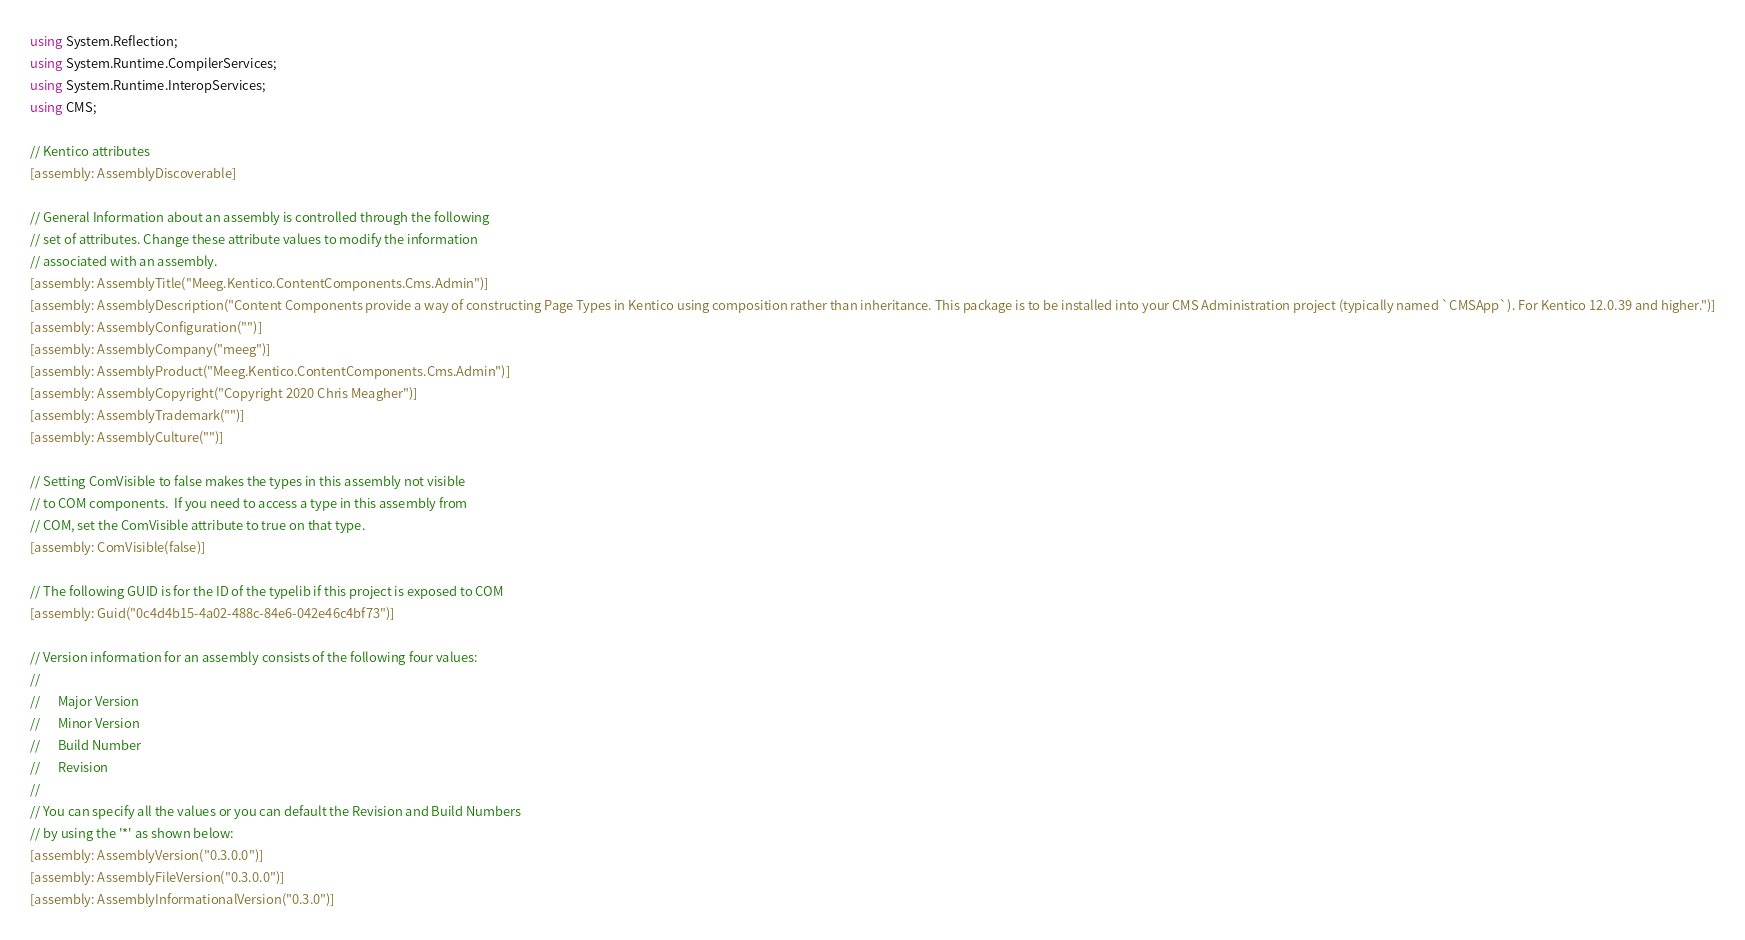<code> <loc_0><loc_0><loc_500><loc_500><_C#_>using System.Reflection;
using System.Runtime.CompilerServices;
using System.Runtime.InteropServices;
using CMS;

// Kentico attributes
[assembly: AssemblyDiscoverable]

// General Information about an assembly is controlled through the following 
// set of attributes. Change these attribute values to modify the information
// associated with an assembly.
[assembly: AssemblyTitle("Meeg.Kentico.ContentComponents.Cms.Admin")]
[assembly: AssemblyDescription("Content Components provide a way of constructing Page Types in Kentico using composition rather than inheritance. This package is to be installed into your CMS Administration project (typically named `CMSApp`). For Kentico 12.0.39 and higher.")]
[assembly: AssemblyConfiguration("")]
[assembly: AssemblyCompany("meeg")]
[assembly: AssemblyProduct("Meeg.Kentico.ContentComponents.Cms.Admin")]
[assembly: AssemblyCopyright("Copyright 2020 Chris Meagher")]
[assembly: AssemblyTrademark("")]
[assembly: AssemblyCulture("")]

// Setting ComVisible to false makes the types in this assembly not visible 
// to COM components.  If you need to access a type in this assembly from 
// COM, set the ComVisible attribute to true on that type.
[assembly: ComVisible(false)]

// The following GUID is for the ID of the typelib if this project is exposed to COM
[assembly: Guid("0c4d4b15-4a02-488c-84e6-042e46c4bf73")]

// Version information for an assembly consists of the following four values:
//
//      Major Version
//      Minor Version 
//      Build Number
//      Revision
//
// You can specify all the values or you can default the Revision and Build Numbers 
// by using the '*' as shown below:
[assembly: AssemblyVersion("0.3.0.0")]
[assembly: AssemblyFileVersion("0.3.0.0")]
[assembly: AssemblyInformationalVersion("0.3.0")]
</code> 